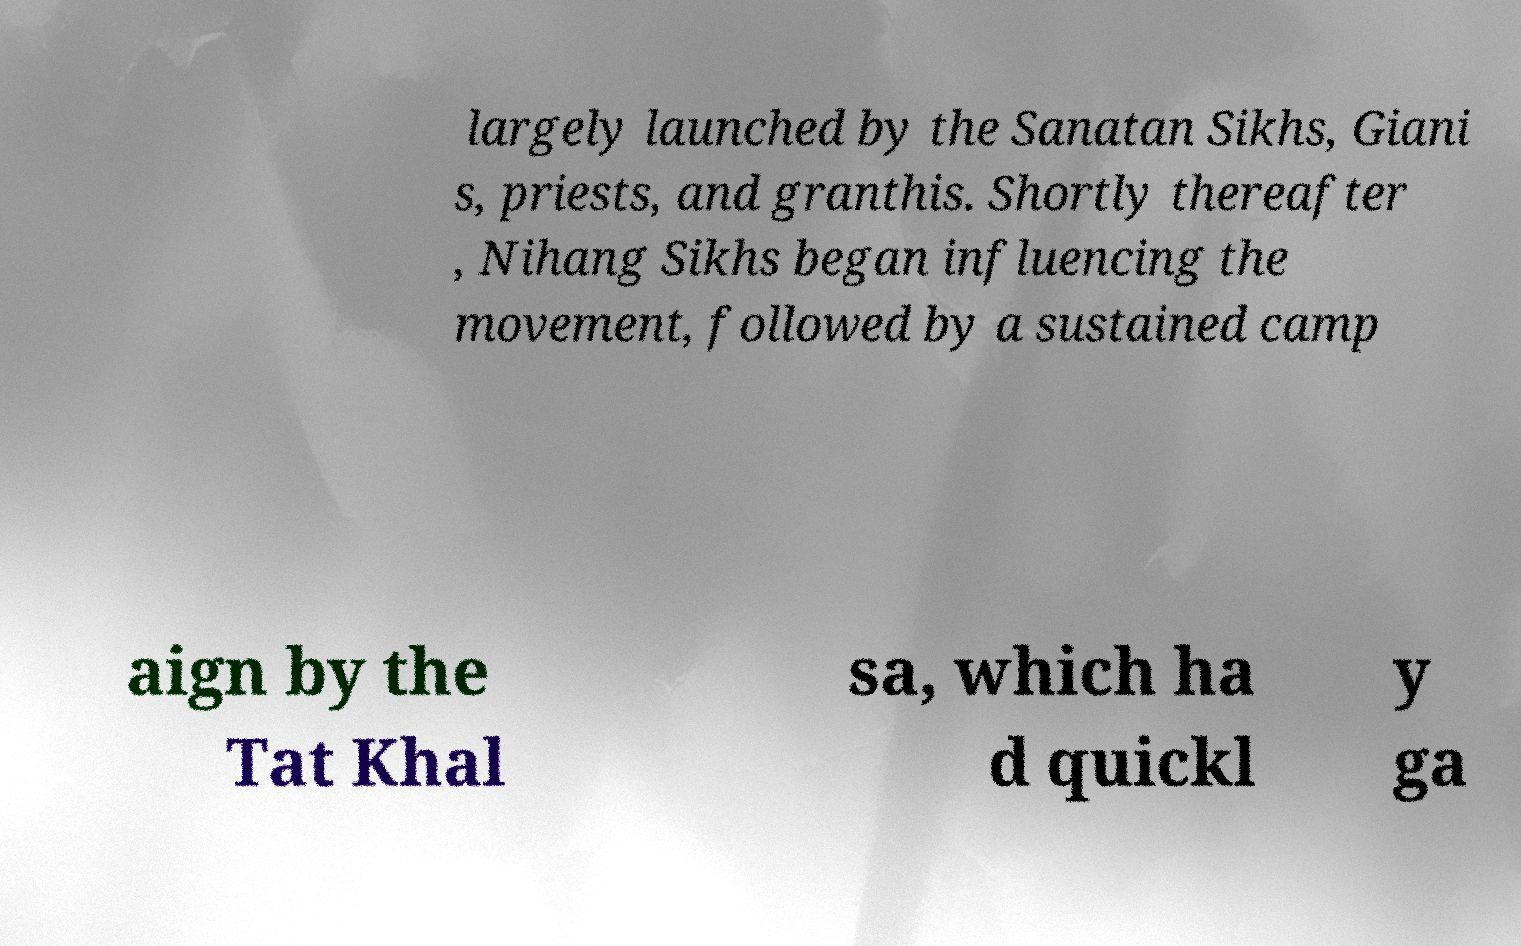Please identify and transcribe the text found in this image. largely launched by the Sanatan Sikhs, Giani s, priests, and granthis. Shortly thereafter , Nihang Sikhs began influencing the movement, followed by a sustained camp aign by the Tat Khal sa, which ha d quickl y ga 